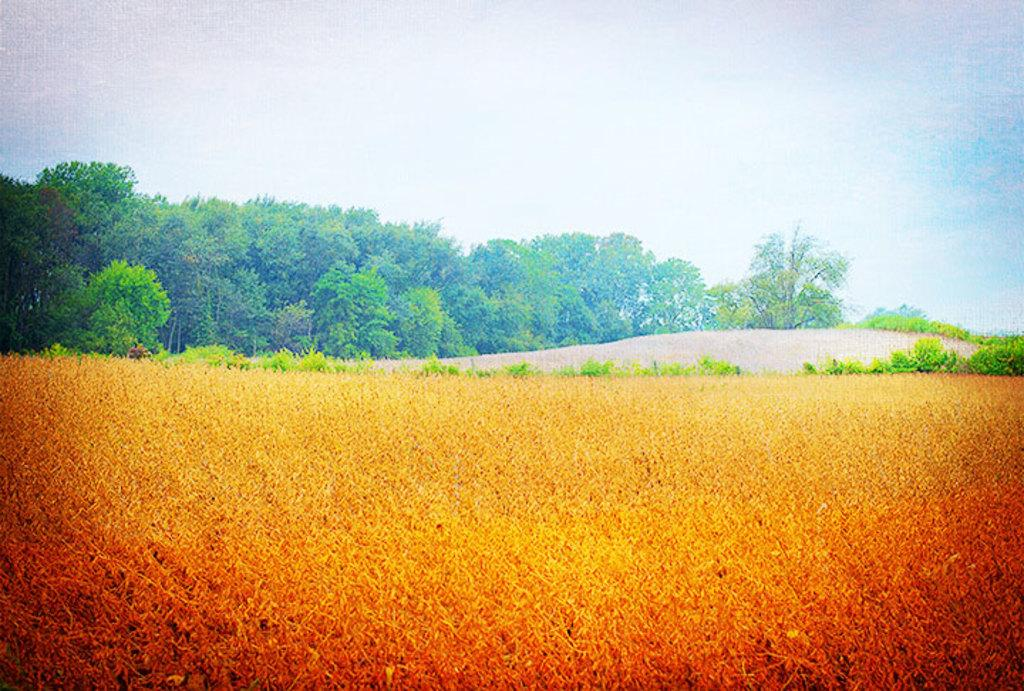What type of vegetation can be seen in the image? There are plants and trees in the image. Can you describe the plants in the image? The plants in the image are not specified, but they are present alongside the trees. How many types of vegetation are visible in the image? There are two types of vegetation visible in the image: plants and trees. How many times does the tree jump in the image? There is no tree jumping in the image, as trees are stationary and do not have the ability to jump. 